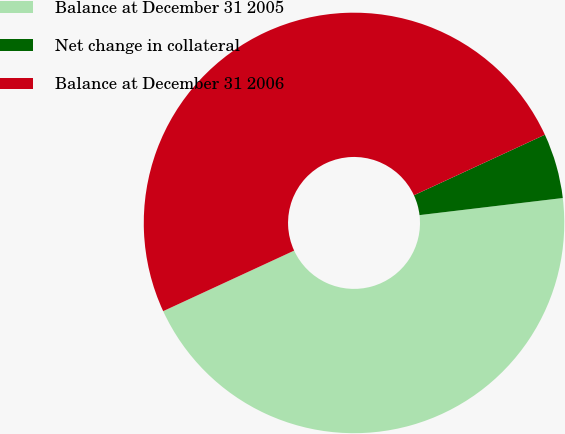Convert chart. <chart><loc_0><loc_0><loc_500><loc_500><pie_chart><fcel>Balance at December 31 2005<fcel>Net change in collateral<fcel>Balance at December 31 2006<nl><fcel>45.0%<fcel>5.0%<fcel>50.0%<nl></chart> 